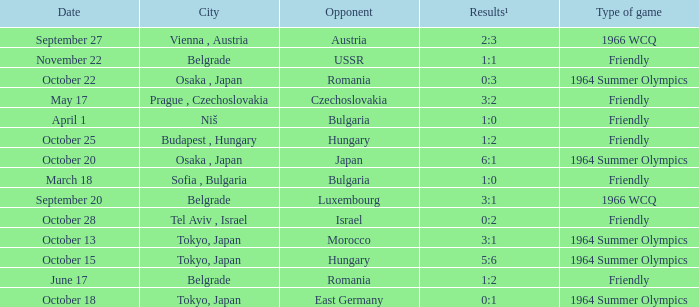What was the opponent on october 28? Israel. 